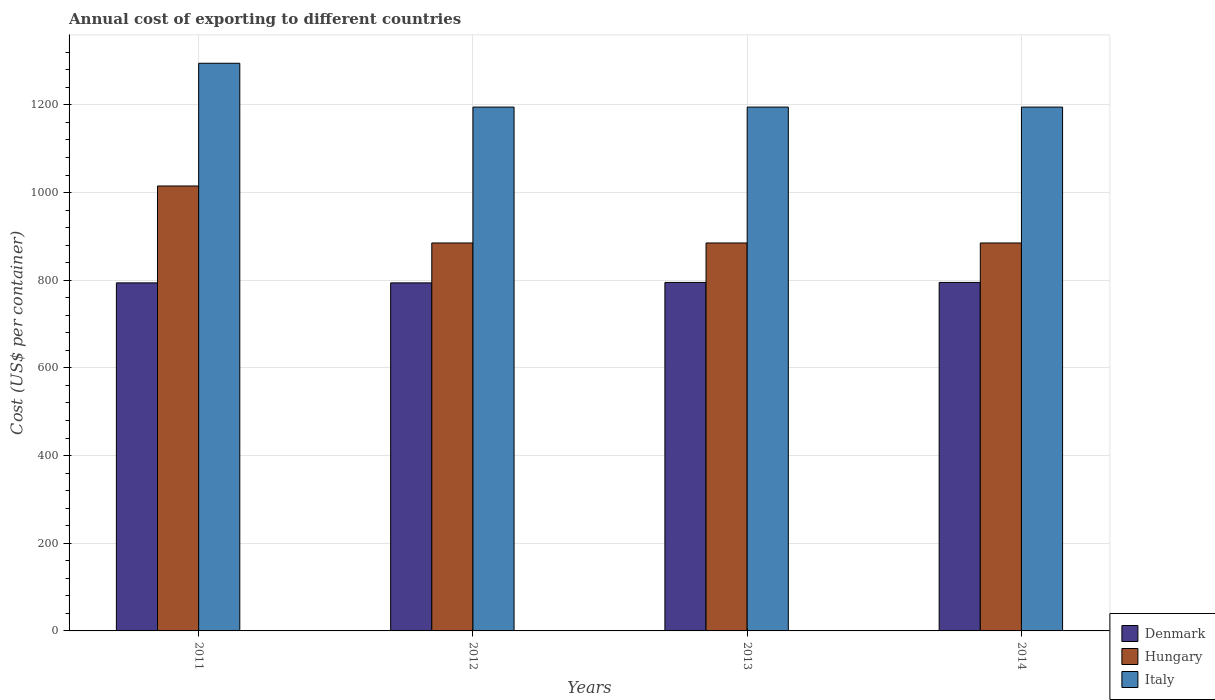How many different coloured bars are there?
Offer a terse response. 3. How many groups of bars are there?
Make the answer very short. 4. Are the number of bars per tick equal to the number of legend labels?
Keep it short and to the point. Yes. What is the label of the 4th group of bars from the left?
Keep it short and to the point. 2014. What is the total annual cost of exporting in Italy in 2012?
Give a very brief answer. 1195. Across all years, what is the maximum total annual cost of exporting in Hungary?
Give a very brief answer. 1015. Across all years, what is the minimum total annual cost of exporting in Denmark?
Offer a very short reply. 794. What is the total total annual cost of exporting in Denmark in the graph?
Your answer should be compact. 3178. What is the difference between the total annual cost of exporting in Italy in 2011 and that in 2014?
Your answer should be compact. 100. What is the difference between the total annual cost of exporting in Italy in 2011 and the total annual cost of exporting in Hungary in 2014?
Offer a terse response. 410. What is the average total annual cost of exporting in Italy per year?
Ensure brevity in your answer.  1220. In the year 2014, what is the difference between the total annual cost of exporting in Italy and total annual cost of exporting in Denmark?
Offer a terse response. 400. What is the ratio of the total annual cost of exporting in Italy in 2012 to that in 2014?
Give a very brief answer. 1. Is the total annual cost of exporting in Hungary in 2013 less than that in 2014?
Provide a succinct answer. No. Is the difference between the total annual cost of exporting in Italy in 2011 and 2012 greater than the difference between the total annual cost of exporting in Denmark in 2011 and 2012?
Make the answer very short. Yes. What is the difference between the highest and the lowest total annual cost of exporting in Denmark?
Offer a terse response. 1. Is the sum of the total annual cost of exporting in Hungary in 2012 and 2014 greater than the maximum total annual cost of exporting in Denmark across all years?
Ensure brevity in your answer.  Yes. What does the 1st bar from the left in 2011 represents?
Make the answer very short. Denmark. What does the 3rd bar from the right in 2013 represents?
Give a very brief answer. Denmark. Is it the case that in every year, the sum of the total annual cost of exporting in Hungary and total annual cost of exporting in Denmark is greater than the total annual cost of exporting in Italy?
Provide a short and direct response. Yes. How many bars are there?
Your answer should be very brief. 12. What is the difference between two consecutive major ticks on the Y-axis?
Offer a very short reply. 200. Are the values on the major ticks of Y-axis written in scientific E-notation?
Offer a terse response. No. How are the legend labels stacked?
Offer a terse response. Vertical. What is the title of the graph?
Provide a succinct answer. Annual cost of exporting to different countries. Does "Jamaica" appear as one of the legend labels in the graph?
Keep it short and to the point. No. What is the label or title of the X-axis?
Provide a short and direct response. Years. What is the label or title of the Y-axis?
Ensure brevity in your answer.  Cost (US$ per container). What is the Cost (US$ per container) in Denmark in 2011?
Your answer should be compact. 794. What is the Cost (US$ per container) in Hungary in 2011?
Provide a succinct answer. 1015. What is the Cost (US$ per container) of Italy in 2011?
Ensure brevity in your answer.  1295. What is the Cost (US$ per container) of Denmark in 2012?
Your response must be concise. 794. What is the Cost (US$ per container) in Hungary in 2012?
Ensure brevity in your answer.  885. What is the Cost (US$ per container) of Italy in 2012?
Provide a succinct answer. 1195. What is the Cost (US$ per container) in Denmark in 2013?
Offer a terse response. 795. What is the Cost (US$ per container) of Hungary in 2013?
Your answer should be compact. 885. What is the Cost (US$ per container) of Italy in 2013?
Give a very brief answer. 1195. What is the Cost (US$ per container) in Denmark in 2014?
Offer a very short reply. 795. What is the Cost (US$ per container) in Hungary in 2014?
Offer a very short reply. 885. What is the Cost (US$ per container) in Italy in 2014?
Keep it short and to the point. 1195. Across all years, what is the maximum Cost (US$ per container) of Denmark?
Ensure brevity in your answer.  795. Across all years, what is the maximum Cost (US$ per container) in Hungary?
Offer a terse response. 1015. Across all years, what is the maximum Cost (US$ per container) in Italy?
Your response must be concise. 1295. Across all years, what is the minimum Cost (US$ per container) in Denmark?
Your answer should be compact. 794. Across all years, what is the minimum Cost (US$ per container) in Hungary?
Offer a terse response. 885. Across all years, what is the minimum Cost (US$ per container) in Italy?
Your answer should be compact. 1195. What is the total Cost (US$ per container) in Denmark in the graph?
Provide a short and direct response. 3178. What is the total Cost (US$ per container) of Hungary in the graph?
Give a very brief answer. 3670. What is the total Cost (US$ per container) of Italy in the graph?
Ensure brevity in your answer.  4880. What is the difference between the Cost (US$ per container) of Hungary in 2011 and that in 2012?
Provide a short and direct response. 130. What is the difference between the Cost (US$ per container) of Italy in 2011 and that in 2012?
Your response must be concise. 100. What is the difference between the Cost (US$ per container) in Denmark in 2011 and that in 2013?
Make the answer very short. -1. What is the difference between the Cost (US$ per container) of Hungary in 2011 and that in 2013?
Make the answer very short. 130. What is the difference between the Cost (US$ per container) in Italy in 2011 and that in 2013?
Ensure brevity in your answer.  100. What is the difference between the Cost (US$ per container) of Denmark in 2011 and that in 2014?
Provide a short and direct response. -1. What is the difference between the Cost (US$ per container) of Hungary in 2011 and that in 2014?
Your answer should be compact. 130. What is the difference between the Cost (US$ per container) of Denmark in 2012 and that in 2013?
Keep it short and to the point. -1. What is the difference between the Cost (US$ per container) in Italy in 2012 and that in 2013?
Provide a short and direct response. 0. What is the difference between the Cost (US$ per container) of Hungary in 2012 and that in 2014?
Your response must be concise. 0. What is the difference between the Cost (US$ per container) in Denmark in 2013 and that in 2014?
Keep it short and to the point. 0. What is the difference between the Cost (US$ per container) in Hungary in 2013 and that in 2014?
Your answer should be very brief. 0. What is the difference between the Cost (US$ per container) of Italy in 2013 and that in 2014?
Provide a succinct answer. 0. What is the difference between the Cost (US$ per container) of Denmark in 2011 and the Cost (US$ per container) of Hungary in 2012?
Your response must be concise. -91. What is the difference between the Cost (US$ per container) in Denmark in 2011 and the Cost (US$ per container) in Italy in 2012?
Give a very brief answer. -401. What is the difference between the Cost (US$ per container) in Hungary in 2011 and the Cost (US$ per container) in Italy in 2012?
Make the answer very short. -180. What is the difference between the Cost (US$ per container) of Denmark in 2011 and the Cost (US$ per container) of Hungary in 2013?
Make the answer very short. -91. What is the difference between the Cost (US$ per container) in Denmark in 2011 and the Cost (US$ per container) in Italy in 2013?
Make the answer very short. -401. What is the difference between the Cost (US$ per container) in Hungary in 2011 and the Cost (US$ per container) in Italy in 2013?
Offer a terse response. -180. What is the difference between the Cost (US$ per container) of Denmark in 2011 and the Cost (US$ per container) of Hungary in 2014?
Provide a succinct answer. -91. What is the difference between the Cost (US$ per container) in Denmark in 2011 and the Cost (US$ per container) in Italy in 2014?
Give a very brief answer. -401. What is the difference between the Cost (US$ per container) in Hungary in 2011 and the Cost (US$ per container) in Italy in 2014?
Make the answer very short. -180. What is the difference between the Cost (US$ per container) in Denmark in 2012 and the Cost (US$ per container) in Hungary in 2013?
Your answer should be very brief. -91. What is the difference between the Cost (US$ per container) in Denmark in 2012 and the Cost (US$ per container) in Italy in 2013?
Give a very brief answer. -401. What is the difference between the Cost (US$ per container) of Hungary in 2012 and the Cost (US$ per container) of Italy in 2013?
Provide a succinct answer. -310. What is the difference between the Cost (US$ per container) of Denmark in 2012 and the Cost (US$ per container) of Hungary in 2014?
Ensure brevity in your answer.  -91. What is the difference between the Cost (US$ per container) of Denmark in 2012 and the Cost (US$ per container) of Italy in 2014?
Offer a terse response. -401. What is the difference between the Cost (US$ per container) in Hungary in 2012 and the Cost (US$ per container) in Italy in 2014?
Offer a very short reply. -310. What is the difference between the Cost (US$ per container) in Denmark in 2013 and the Cost (US$ per container) in Hungary in 2014?
Your answer should be very brief. -90. What is the difference between the Cost (US$ per container) in Denmark in 2013 and the Cost (US$ per container) in Italy in 2014?
Keep it short and to the point. -400. What is the difference between the Cost (US$ per container) in Hungary in 2013 and the Cost (US$ per container) in Italy in 2014?
Keep it short and to the point. -310. What is the average Cost (US$ per container) of Denmark per year?
Your answer should be very brief. 794.5. What is the average Cost (US$ per container) in Hungary per year?
Provide a succinct answer. 917.5. What is the average Cost (US$ per container) of Italy per year?
Your response must be concise. 1220. In the year 2011, what is the difference between the Cost (US$ per container) of Denmark and Cost (US$ per container) of Hungary?
Offer a very short reply. -221. In the year 2011, what is the difference between the Cost (US$ per container) of Denmark and Cost (US$ per container) of Italy?
Keep it short and to the point. -501. In the year 2011, what is the difference between the Cost (US$ per container) of Hungary and Cost (US$ per container) of Italy?
Offer a very short reply. -280. In the year 2012, what is the difference between the Cost (US$ per container) in Denmark and Cost (US$ per container) in Hungary?
Keep it short and to the point. -91. In the year 2012, what is the difference between the Cost (US$ per container) in Denmark and Cost (US$ per container) in Italy?
Your answer should be compact. -401. In the year 2012, what is the difference between the Cost (US$ per container) of Hungary and Cost (US$ per container) of Italy?
Keep it short and to the point. -310. In the year 2013, what is the difference between the Cost (US$ per container) of Denmark and Cost (US$ per container) of Hungary?
Ensure brevity in your answer.  -90. In the year 2013, what is the difference between the Cost (US$ per container) in Denmark and Cost (US$ per container) in Italy?
Provide a succinct answer. -400. In the year 2013, what is the difference between the Cost (US$ per container) of Hungary and Cost (US$ per container) of Italy?
Ensure brevity in your answer.  -310. In the year 2014, what is the difference between the Cost (US$ per container) of Denmark and Cost (US$ per container) of Hungary?
Your answer should be compact. -90. In the year 2014, what is the difference between the Cost (US$ per container) of Denmark and Cost (US$ per container) of Italy?
Ensure brevity in your answer.  -400. In the year 2014, what is the difference between the Cost (US$ per container) in Hungary and Cost (US$ per container) in Italy?
Keep it short and to the point. -310. What is the ratio of the Cost (US$ per container) in Denmark in 2011 to that in 2012?
Provide a succinct answer. 1. What is the ratio of the Cost (US$ per container) of Hungary in 2011 to that in 2012?
Offer a terse response. 1.15. What is the ratio of the Cost (US$ per container) of Italy in 2011 to that in 2012?
Provide a short and direct response. 1.08. What is the ratio of the Cost (US$ per container) in Hungary in 2011 to that in 2013?
Ensure brevity in your answer.  1.15. What is the ratio of the Cost (US$ per container) of Italy in 2011 to that in 2013?
Offer a terse response. 1.08. What is the ratio of the Cost (US$ per container) of Hungary in 2011 to that in 2014?
Offer a very short reply. 1.15. What is the ratio of the Cost (US$ per container) in Italy in 2011 to that in 2014?
Keep it short and to the point. 1.08. What is the ratio of the Cost (US$ per container) of Denmark in 2012 to that in 2013?
Give a very brief answer. 1. What is the ratio of the Cost (US$ per container) in Hungary in 2012 to that in 2013?
Your response must be concise. 1. What is the ratio of the Cost (US$ per container) in Denmark in 2012 to that in 2014?
Offer a terse response. 1. What is the ratio of the Cost (US$ per container) of Italy in 2012 to that in 2014?
Your answer should be very brief. 1. What is the ratio of the Cost (US$ per container) in Italy in 2013 to that in 2014?
Provide a short and direct response. 1. What is the difference between the highest and the second highest Cost (US$ per container) in Hungary?
Keep it short and to the point. 130. What is the difference between the highest and the lowest Cost (US$ per container) of Denmark?
Make the answer very short. 1. What is the difference between the highest and the lowest Cost (US$ per container) of Hungary?
Offer a terse response. 130. What is the difference between the highest and the lowest Cost (US$ per container) of Italy?
Offer a very short reply. 100. 